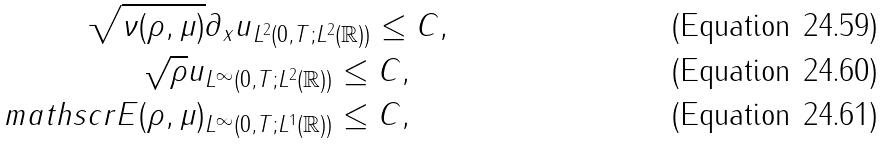Convert formula to latex. <formula><loc_0><loc_0><loc_500><loc_500>\| \sqrt { \nu ( \rho , \mu ) } & \partial _ { x } u \| _ { L ^ { 2 } ( 0 , T ; L ^ { 2 } ( \mathbb { R } ) ) } \leq C , \\ \| \sqrt { \rho } u \| & _ { L ^ { \infty } ( 0 , T ; L ^ { 2 } ( \mathbb { R } ) ) } \leq C , \\ \| \ m a t h s c r { E } ( \rho , \mu ) & \| _ { L ^ { \infty } ( 0 , T ; L ^ { 1 } ( \mathbb { R } ) ) } \leq C ,</formula> 